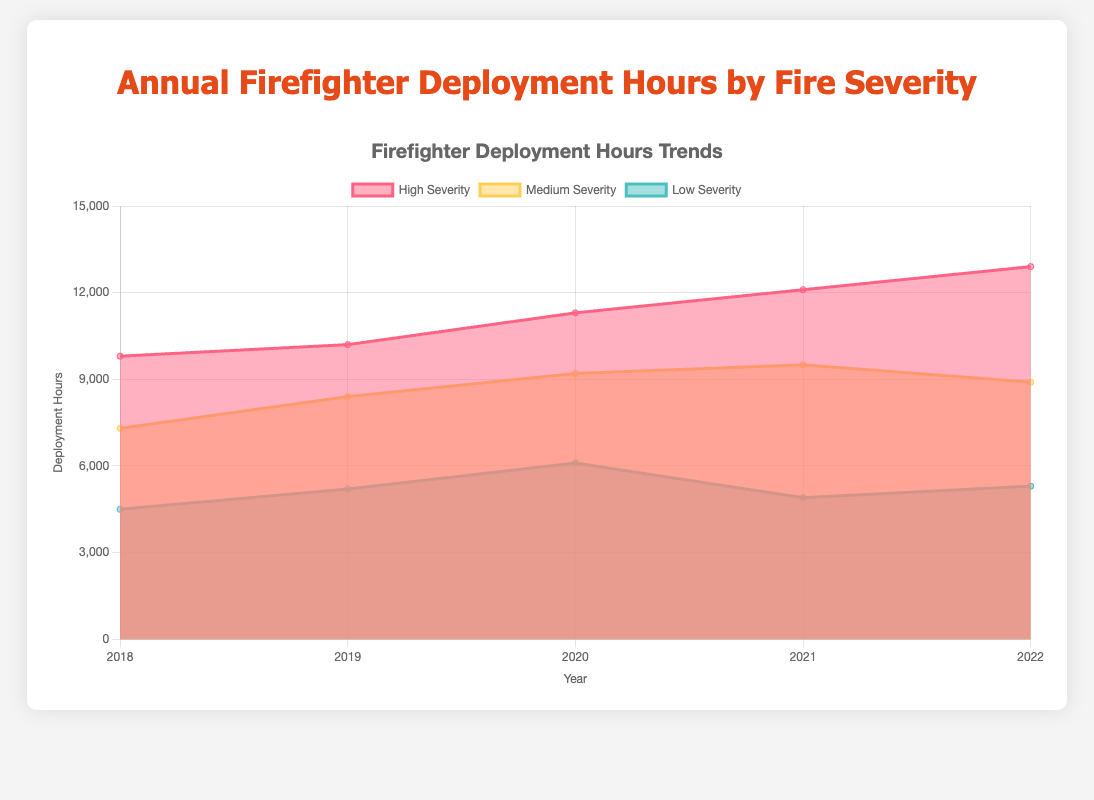What is the overall trend in high-severity firefighter deployment hours from 2018 to 2022? From the chart, it can be seen that the high-severity firefighter deployment hours are increasing year over year. Specifically, they start from 9800 hours in 2018 and rise to 12900 hours in 2022.
Answer: Increasing Which year had the highest total firefighter deployment hours? To determine this, we need to sum the deployment hours across all severity levels for each year. For 2022: 5300 + 8900 + 12900 = 27100 hours; for 2021: 4900 + 9500 + 12100 = 26500 hours; other years have smaller totals. Thus, 2022 has the highest total deployment hours.
Answer: 2022 What is the total deployment hours for medium severity fires in 2019 and 2020? Adding the medium-severity deployment hours for both years results in 8400 (for 2019) + 9200 (for 2020) = 17600 hours.
Answer: 17600 Which severity level shows the greatest increase in deployment hours from 2018 to 2022? By comparing 2018 and 2022 data, for low severity: 5300 - 4500 = 800 hours increase, for medium severity: 8900 - 7300 = 1600 hours increase, for high severity: 12900 - 9800 = 3100 hours increase. High severity has the greatest increase.
Answer: High severity How did the total firefighter deployment hours for low severity fires change from 2020 to 2021? Comparing 2020 and 2021 data for low severity fires: 4900 hours (in 2021) is a decrease from 6100 hours (in 2020). Specifically, 6100 - 4900 = 1200 hours decrease.
Answer: Decrease by 1200 Which year saw the least deployment hours for low severity fires? Reviewing the data for low severity fire deployment hours: 2018: 4500, 2019: 5200, 2020: 6100, 2021: 4900, 2022: 5300. The least hours are in 2018 with 4500 hours.
Answer: 2018 What proportion of the 2022 deployment hours was allocated to high severity fires? In 2022, the deployment hours for high severity fires were 12900 out of a total of 27100. The proportion is 12900 / 27100 ≈ 0.476, or about 47.6%.
Answer: 47.6% Did the deployment hours for medium severity fires peak during the data range, and if so, which year? Observing the medium severity data: 2018: 7300, 2019: 8400, 2020: 9200, 2021: 9500, 2022: 8900. They peak in 2021 with 9500 hours.
Answer: 2021 What is the average number of deployment hours per severity level for the year 2020? Adding the hours for 2020: 6100 (low) + 9200 (medium) + 11300 (high) = 26600. Dividing by 3 severity levels, 26600 / 3 ≈ 8866.67 hours.
Answer: 8866.67 